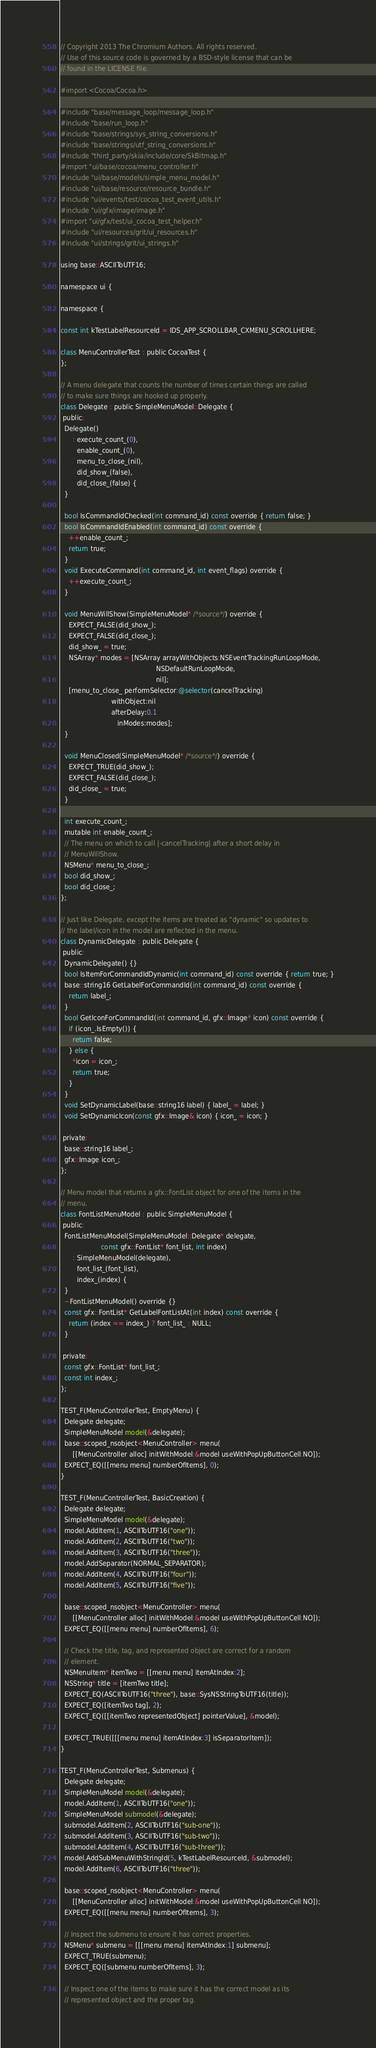Convert code to text. <code><loc_0><loc_0><loc_500><loc_500><_ObjectiveC_>// Copyright 2013 The Chromium Authors. All rights reserved.
// Use of this source code is governed by a BSD-style license that can be
// found in the LICENSE file.

#import <Cocoa/Cocoa.h>

#include "base/message_loop/message_loop.h"
#include "base/run_loop.h"
#include "base/strings/sys_string_conversions.h"
#include "base/strings/utf_string_conversions.h"
#include "third_party/skia/include/core/SkBitmap.h"
#import "ui/base/cocoa/menu_controller.h"
#include "ui/base/models/simple_menu_model.h"
#include "ui/base/resource/resource_bundle.h"
#include "ui/events/test/cocoa_test_event_utils.h"
#include "ui/gfx/image/image.h"
#import "ui/gfx/test/ui_cocoa_test_helper.h"
#include "ui/resources/grit/ui_resources.h"
#include "ui/strings/grit/ui_strings.h"

using base::ASCIIToUTF16;

namespace ui {

namespace {

const int kTestLabelResourceId = IDS_APP_SCROLLBAR_CXMENU_SCROLLHERE;

class MenuControllerTest : public CocoaTest {
};

// A menu delegate that counts the number of times certain things are called
// to make sure things are hooked up properly.
class Delegate : public SimpleMenuModel::Delegate {
 public:
  Delegate()
      : execute_count_(0),
        enable_count_(0),
        menu_to_close_(nil),
        did_show_(false),
        did_close_(false) {
  }

  bool IsCommandIdChecked(int command_id) const override { return false; }
  bool IsCommandIdEnabled(int command_id) const override {
    ++enable_count_;
    return true;
  }
  void ExecuteCommand(int command_id, int event_flags) override {
    ++execute_count_;
  }

  void MenuWillShow(SimpleMenuModel* /*source*/) override {
    EXPECT_FALSE(did_show_);
    EXPECT_FALSE(did_close_);
    did_show_ = true;
    NSArray* modes = [NSArray arrayWithObjects:NSEventTrackingRunLoopMode,
                                               NSDefaultRunLoopMode,
                                               nil];
    [menu_to_close_ performSelector:@selector(cancelTracking)
                         withObject:nil
                         afterDelay:0.1
                            inModes:modes];
  }

  void MenuClosed(SimpleMenuModel* /*source*/) override {
    EXPECT_TRUE(did_show_);
    EXPECT_FALSE(did_close_);
    did_close_ = true;
  }

  int execute_count_;
  mutable int enable_count_;
  // The menu on which to call |-cancelTracking| after a short delay in
  // MenuWillShow.
  NSMenu* menu_to_close_;
  bool did_show_;
  bool did_close_;
};

// Just like Delegate, except the items are treated as "dynamic" so updates to
// the label/icon in the model are reflected in the menu.
class DynamicDelegate : public Delegate {
 public:
  DynamicDelegate() {}
  bool IsItemForCommandIdDynamic(int command_id) const override { return true; }
  base::string16 GetLabelForCommandId(int command_id) const override {
    return label_;
  }
  bool GetIconForCommandId(int command_id, gfx::Image* icon) const override {
    if (icon_.IsEmpty()) {
      return false;
    } else {
      *icon = icon_;
      return true;
    }
  }
  void SetDynamicLabel(base::string16 label) { label_ = label; }
  void SetDynamicIcon(const gfx::Image& icon) { icon_ = icon; }

 private:
  base::string16 label_;
  gfx::Image icon_;
};

// Menu model that returns a gfx::FontList object for one of the items in the
// menu.
class FontListMenuModel : public SimpleMenuModel {
 public:
  FontListMenuModel(SimpleMenuModel::Delegate* delegate,
                    const gfx::FontList* font_list, int index)
      : SimpleMenuModel(delegate),
        font_list_(font_list),
        index_(index) {
  }
  ~FontListMenuModel() override {}
  const gfx::FontList* GetLabelFontListAt(int index) const override {
    return (index == index_) ? font_list_ : NULL;
  }

 private:
  const gfx::FontList* font_list_;
  const int index_;
};

TEST_F(MenuControllerTest, EmptyMenu) {
  Delegate delegate;
  SimpleMenuModel model(&delegate);
  base::scoped_nsobject<MenuController> menu(
      [[MenuController alloc] initWithModel:&model useWithPopUpButtonCell:NO]);
  EXPECT_EQ([[menu menu] numberOfItems], 0);
}

TEST_F(MenuControllerTest, BasicCreation) {
  Delegate delegate;
  SimpleMenuModel model(&delegate);
  model.AddItem(1, ASCIIToUTF16("one"));
  model.AddItem(2, ASCIIToUTF16("two"));
  model.AddItem(3, ASCIIToUTF16("three"));
  model.AddSeparator(NORMAL_SEPARATOR);
  model.AddItem(4, ASCIIToUTF16("four"));
  model.AddItem(5, ASCIIToUTF16("five"));

  base::scoped_nsobject<MenuController> menu(
      [[MenuController alloc] initWithModel:&model useWithPopUpButtonCell:NO]);
  EXPECT_EQ([[menu menu] numberOfItems], 6);

  // Check the title, tag, and represented object are correct for a random
  // element.
  NSMenuItem* itemTwo = [[menu menu] itemAtIndex:2];
  NSString* title = [itemTwo title];
  EXPECT_EQ(ASCIIToUTF16("three"), base::SysNSStringToUTF16(title));
  EXPECT_EQ([itemTwo tag], 2);
  EXPECT_EQ([[itemTwo representedObject] pointerValue], &model);

  EXPECT_TRUE([[[menu menu] itemAtIndex:3] isSeparatorItem]);
}

TEST_F(MenuControllerTest, Submenus) {
  Delegate delegate;
  SimpleMenuModel model(&delegate);
  model.AddItem(1, ASCIIToUTF16("one"));
  SimpleMenuModel submodel(&delegate);
  submodel.AddItem(2, ASCIIToUTF16("sub-one"));
  submodel.AddItem(3, ASCIIToUTF16("sub-two"));
  submodel.AddItem(4, ASCIIToUTF16("sub-three"));
  model.AddSubMenuWithStringId(5, kTestLabelResourceId, &submodel);
  model.AddItem(6, ASCIIToUTF16("three"));

  base::scoped_nsobject<MenuController> menu(
      [[MenuController alloc] initWithModel:&model useWithPopUpButtonCell:NO]);
  EXPECT_EQ([[menu menu] numberOfItems], 3);

  // Inspect the submenu to ensure it has correct properties.
  NSMenu* submenu = [[[menu menu] itemAtIndex:1] submenu];
  EXPECT_TRUE(submenu);
  EXPECT_EQ([submenu numberOfItems], 3);

  // Inspect one of the items to make sure it has the correct model as its
  // represented object and the proper tag.</code> 